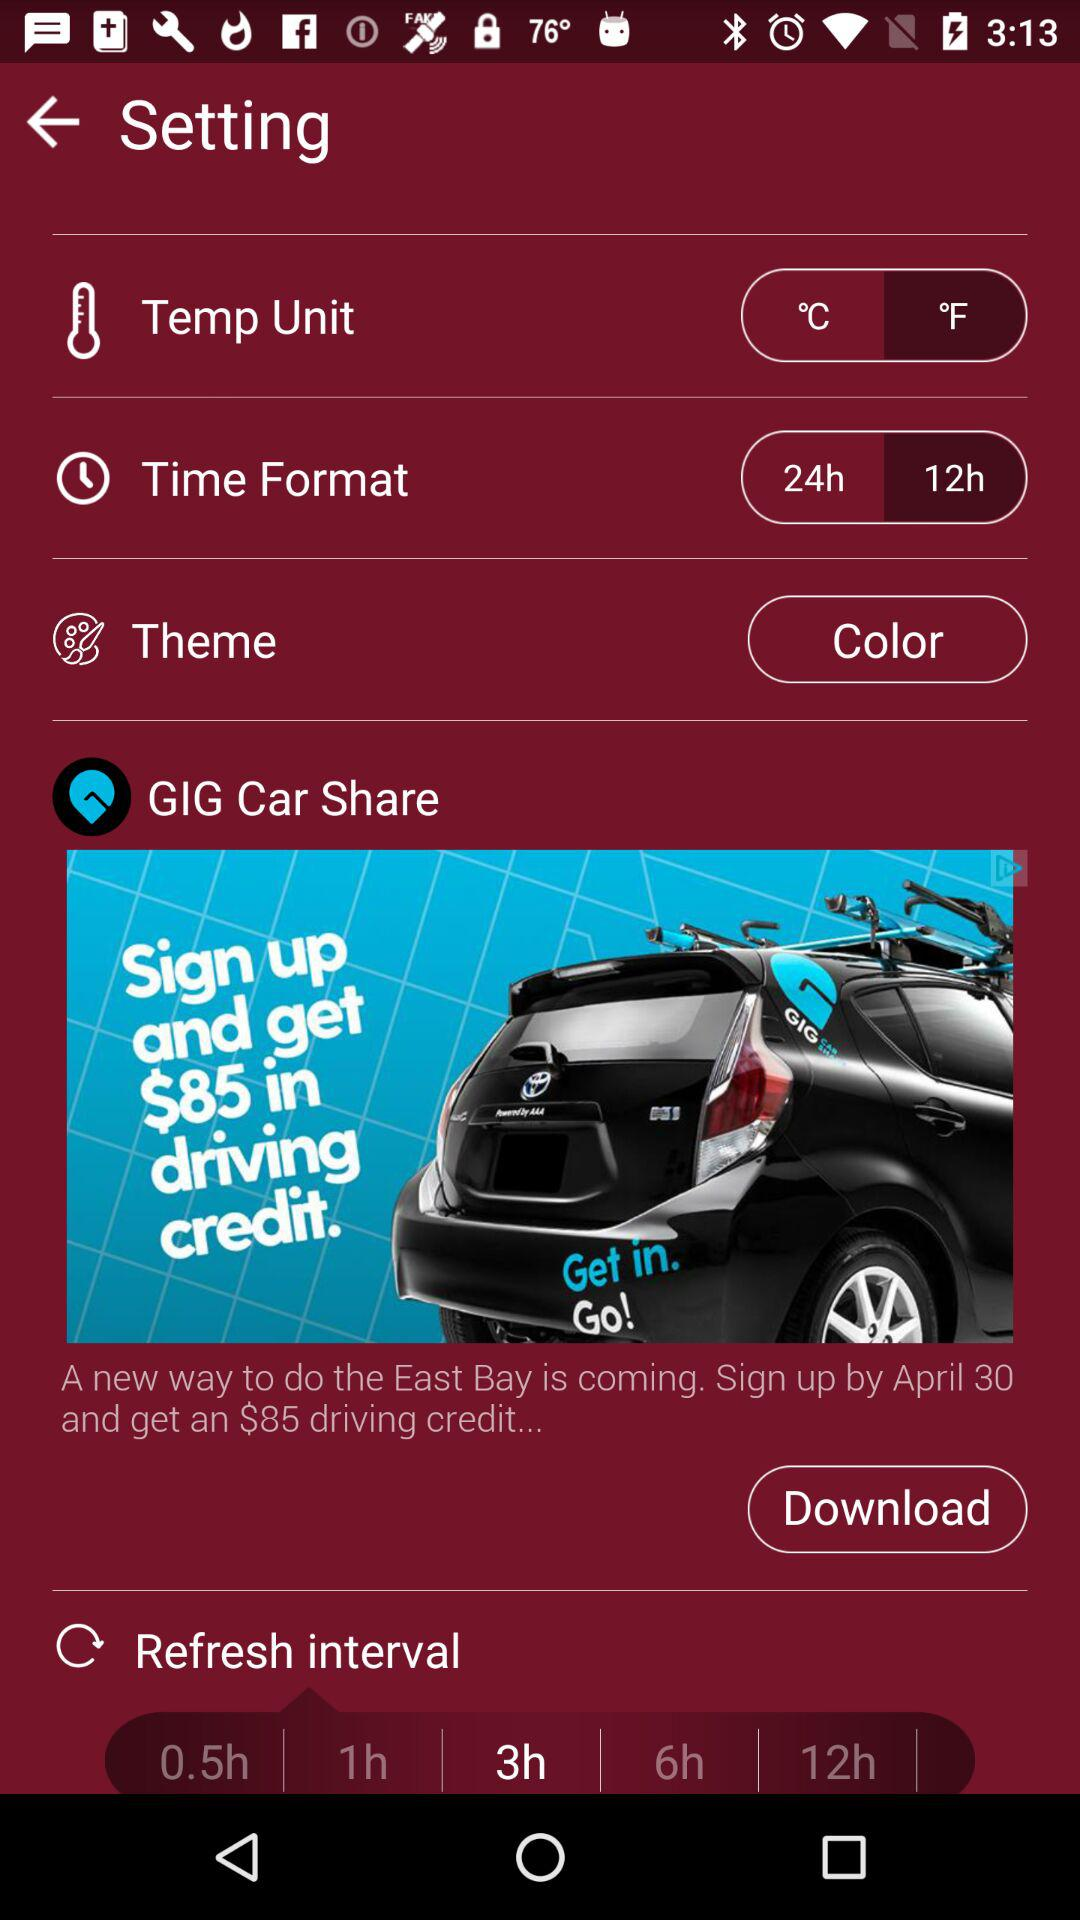What is the selected refresh interval? The selected refresh interval is 3h. 